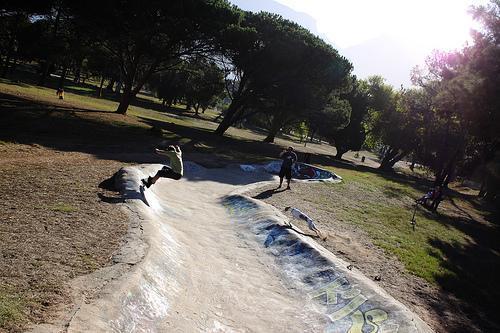How many dogs are shown?
Give a very brief answer. 1. 